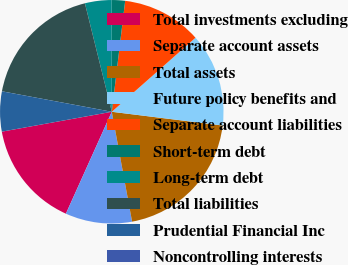<chart> <loc_0><loc_0><loc_500><loc_500><pie_chart><fcel>Total investments excluding<fcel>Separate account assets<fcel>Total assets<fcel>Future policy benefits and<fcel>Separate account liabilities<fcel>Short-term debt<fcel>Long-term debt<fcel>Total liabilities<fcel>Prudential Financial Inc<fcel>Noncontrolling interests<nl><fcel>15.42%<fcel>9.64%<fcel>20.13%<fcel>13.49%<fcel>11.56%<fcel>1.93%<fcel>3.85%<fcel>18.2%<fcel>5.78%<fcel>0.0%<nl></chart> 